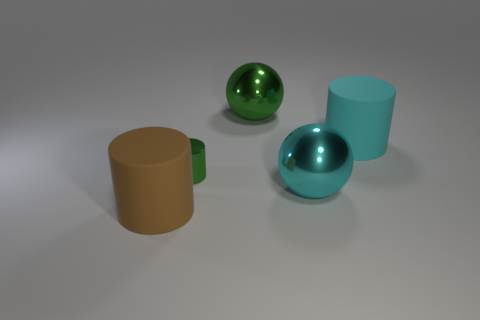What shape is the big matte thing that is left of the big cyan rubber cylinder?
Your answer should be compact. Cylinder. What is the shape of the other thing that is the same color as the tiny shiny object?
Your answer should be very brief. Sphere. What number of brown matte objects have the same size as the cyan metallic sphere?
Make the answer very short. 1. What color is the tiny cylinder?
Keep it short and to the point. Green. There is a small cylinder; is its color the same as the large thing that is left of the big green metallic ball?
Provide a succinct answer. No. There is a green sphere that is the same material as the tiny green thing; what size is it?
Make the answer very short. Large. Are there any big balls that have the same color as the small thing?
Keep it short and to the point. Yes. What number of objects are spheres that are in front of the green metallic cylinder or matte objects?
Provide a succinct answer. 3. Do the large brown thing and the big cyan object in front of the large cyan cylinder have the same material?
Give a very brief answer. No. What size is the metallic ball that is the same color as the shiny cylinder?
Offer a very short reply. Large. 